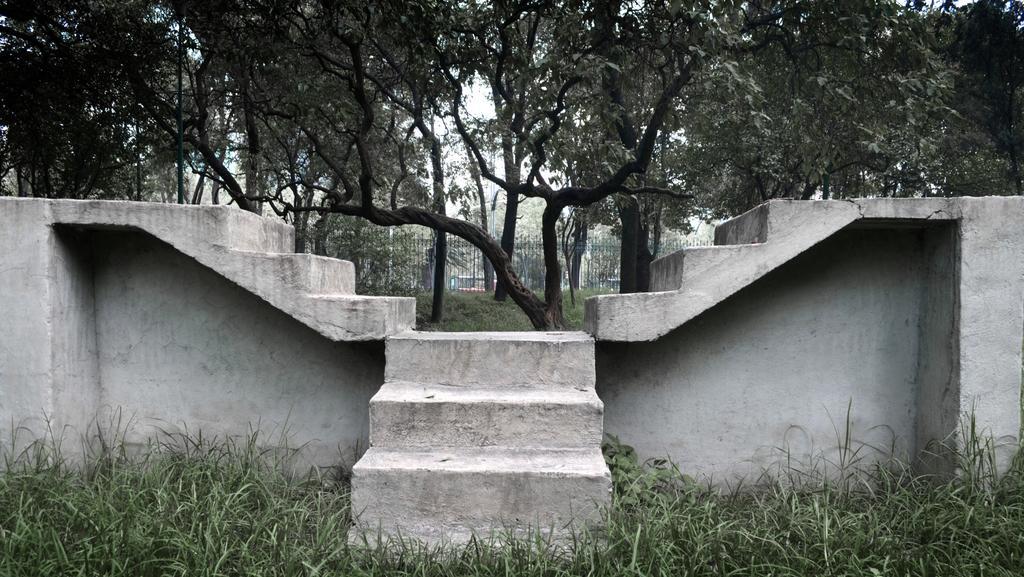What is the main feature in the middle of the image? There is a set of stairs at the center of the image. What type of ground is visible at the bottom of the image? There is grass at the bottom of the image. What can be seen in the distance in the image? There are trees in the background of the image. What type of stew is being cooked in the image? There is no stew present in the image; it features a set of stairs, grass, and trees. Can you see a van parked near the stairs in the image? There is no van present in the image. 